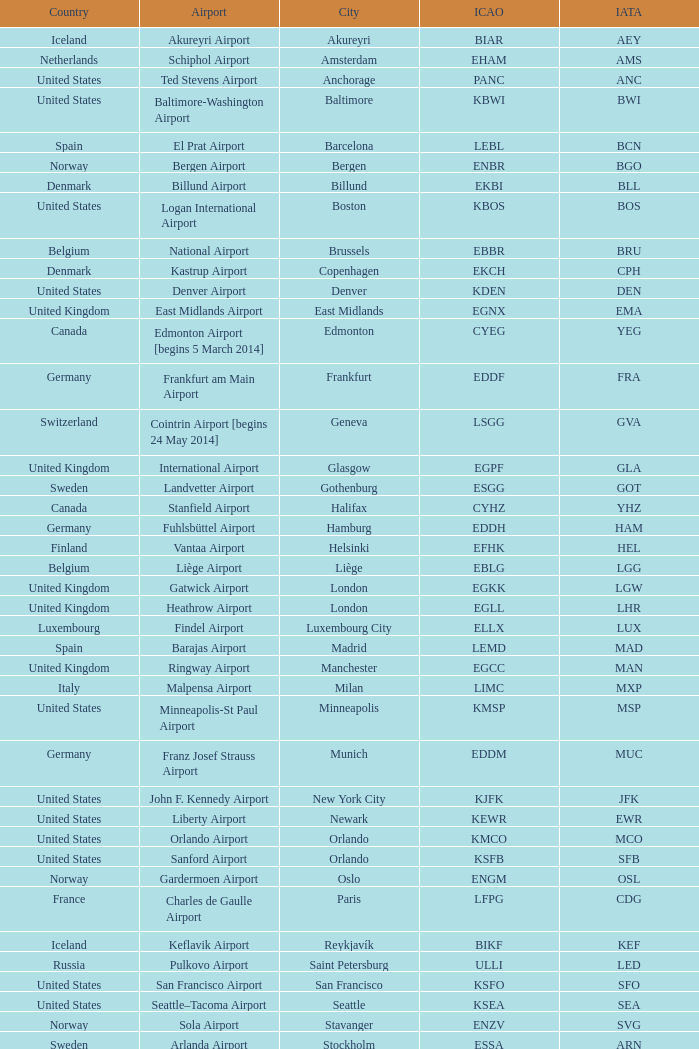What is the IATA OF Akureyri? AEY. 